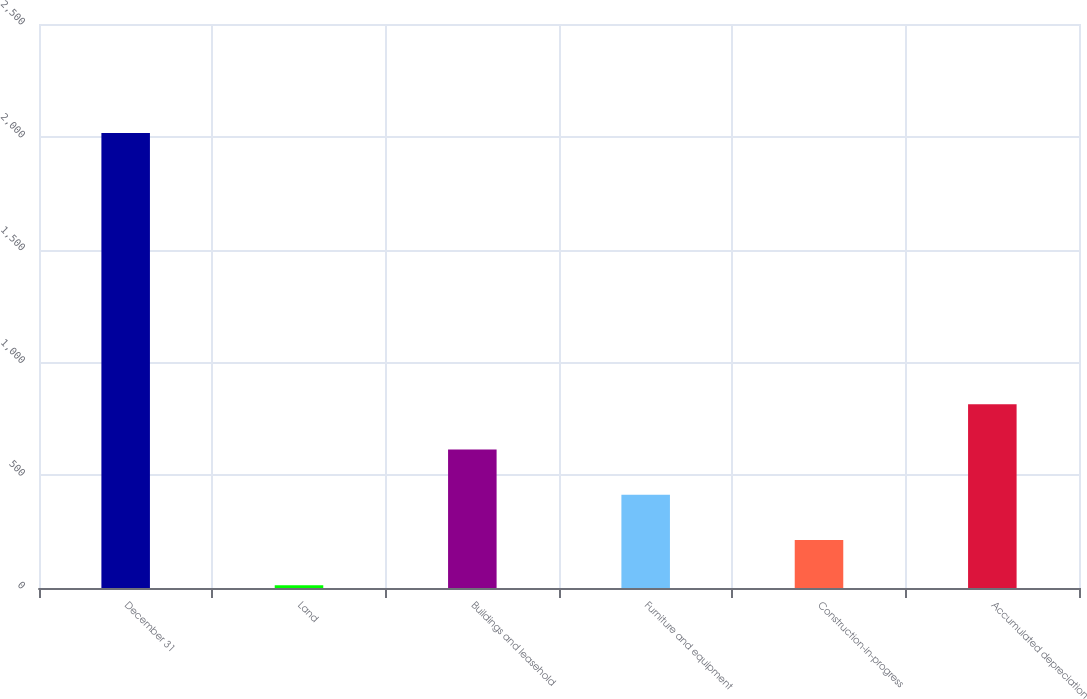Convert chart to OTSL. <chart><loc_0><loc_0><loc_500><loc_500><bar_chart><fcel>December 31<fcel>Land<fcel>Buildings and leasehold<fcel>Furniture and equipment<fcel>Construction-in-progress<fcel>Accumulated depreciation<nl><fcel>2017<fcel>12<fcel>613.5<fcel>413<fcel>212.5<fcel>814<nl></chart> 